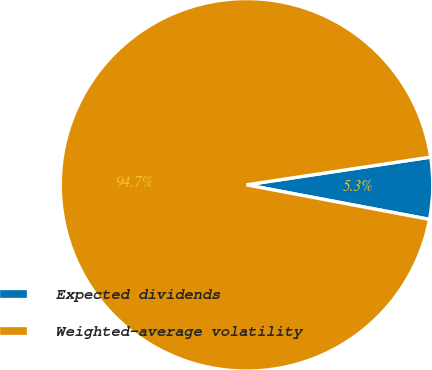Convert chart to OTSL. <chart><loc_0><loc_0><loc_500><loc_500><pie_chart><fcel>Expected dividends<fcel>Weighted-average volatility<nl><fcel>5.35%<fcel>94.65%<nl></chart> 